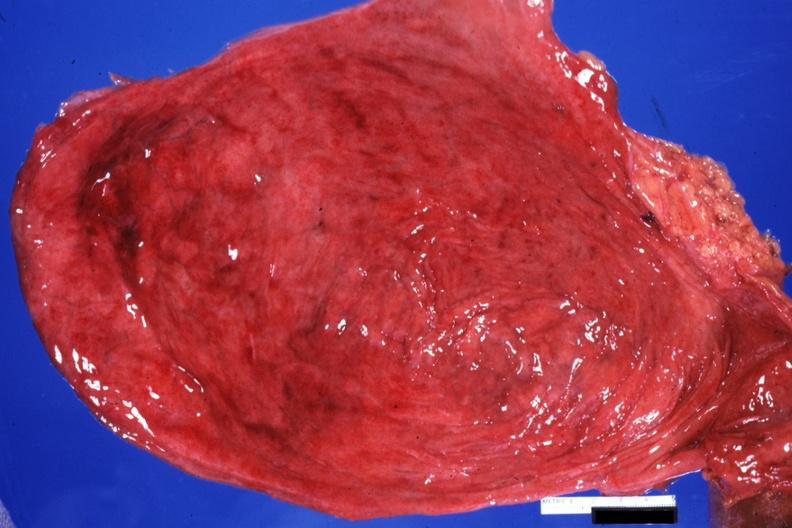s palmar crease normal present?
Answer the question using a single word or phrase. No 